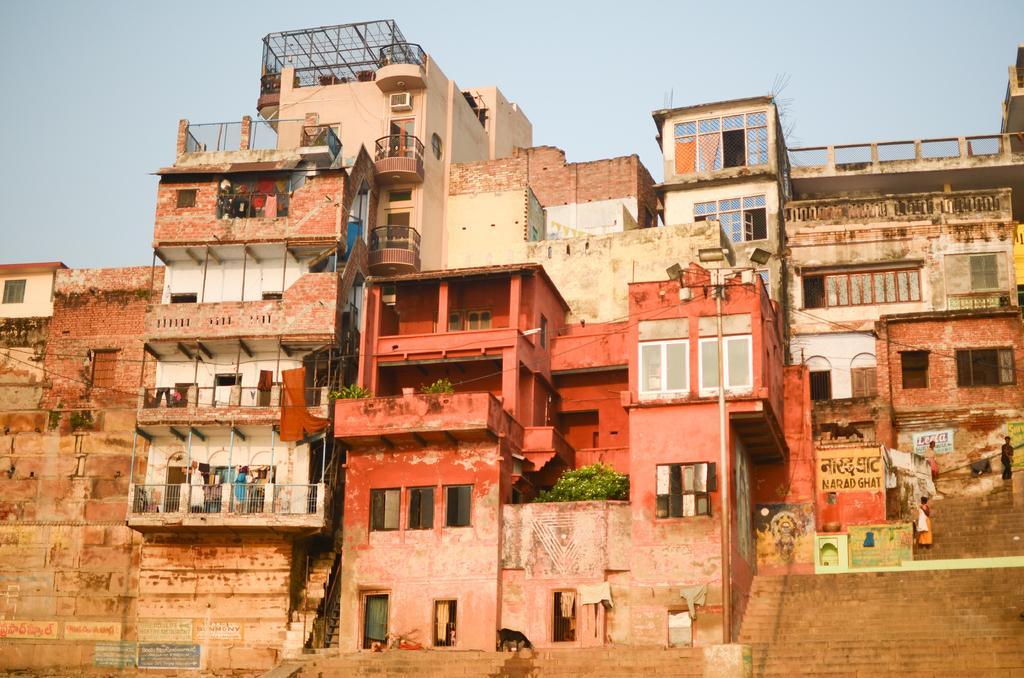Could you give a brief overview of what you see in this image? In the middle of the image there are some buildings, on the buildings there are some plants. Behind the building there is sky. 